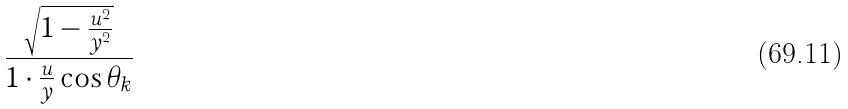Convert formula to latex. <formula><loc_0><loc_0><loc_500><loc_500>\frac { \sqrt { 1 - \frac { u ^ { 2 } } { y ^ { 2 } } } } { 1 \cdot \frac { u } { y } \cos \theta _ { k } }</formula> 